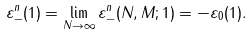Convert formula to latex. <formula><loc_0><loc_0><loc_500><loc_500>\varepsilon _ { - } ^ { n } ( 1 ) = \lim _ { N \to \infty } \varepsilon _ { - } ^ { n } ( N , M ; 1 ) = - \varepsilon _ { 0 } ( 1 ) .</formula> 